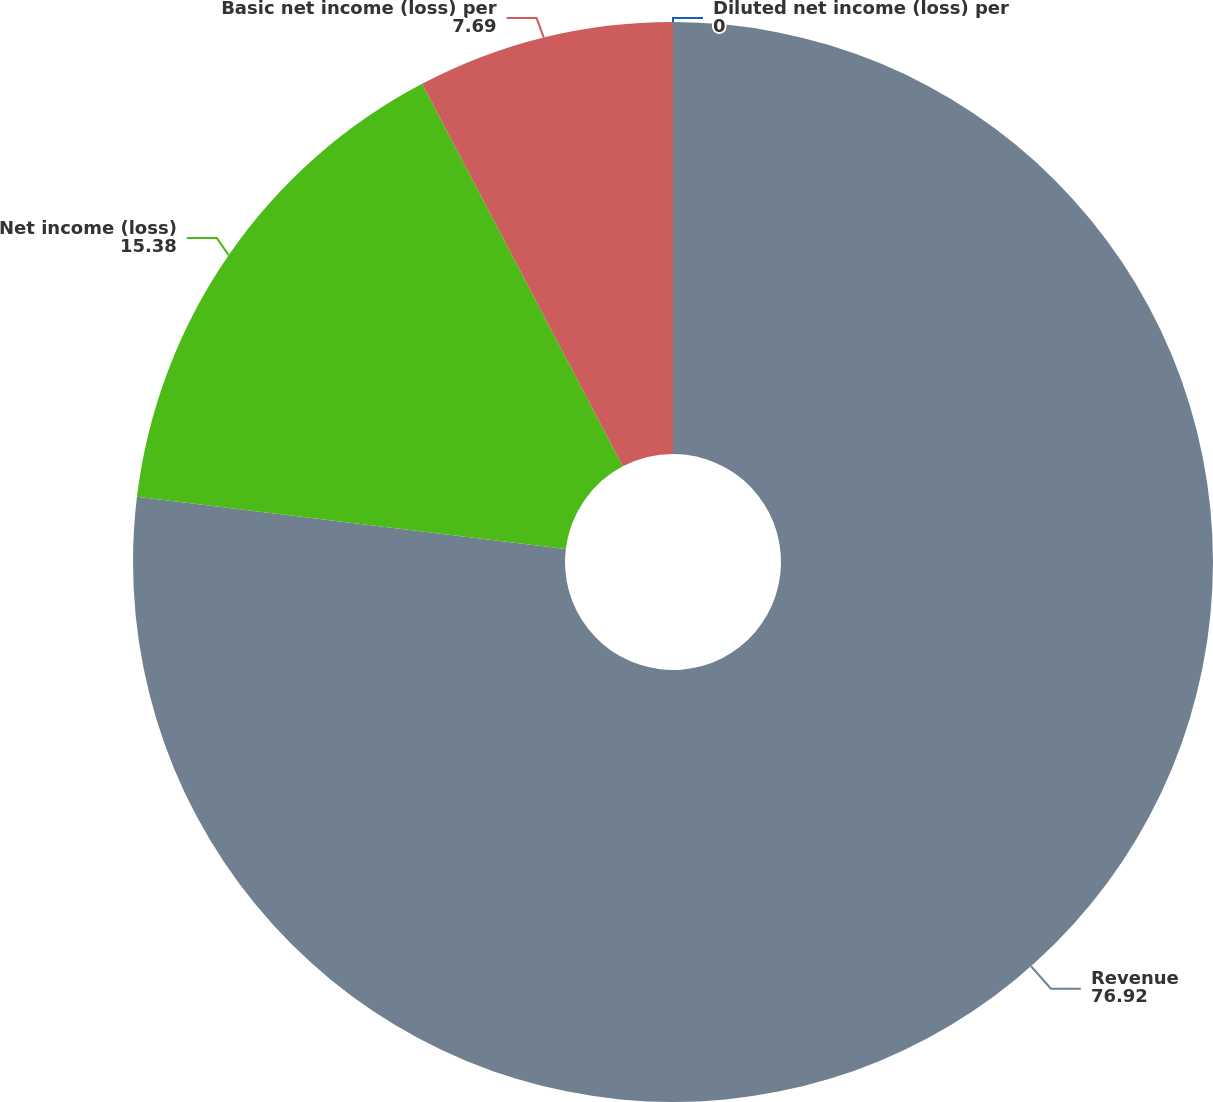Convert chart. <chart><loc_0><loc_0><loc_500><loc_500><pie_chart><fcel>Revenue<fcel>Net income (loss)<fcel>Basic net income (loss) per<fcel>Diluted net income (loss) per<nl><fcel>76.92%<fcel>15.38%<fcel>7.69%<fcel>0.0%<nl></chart> 